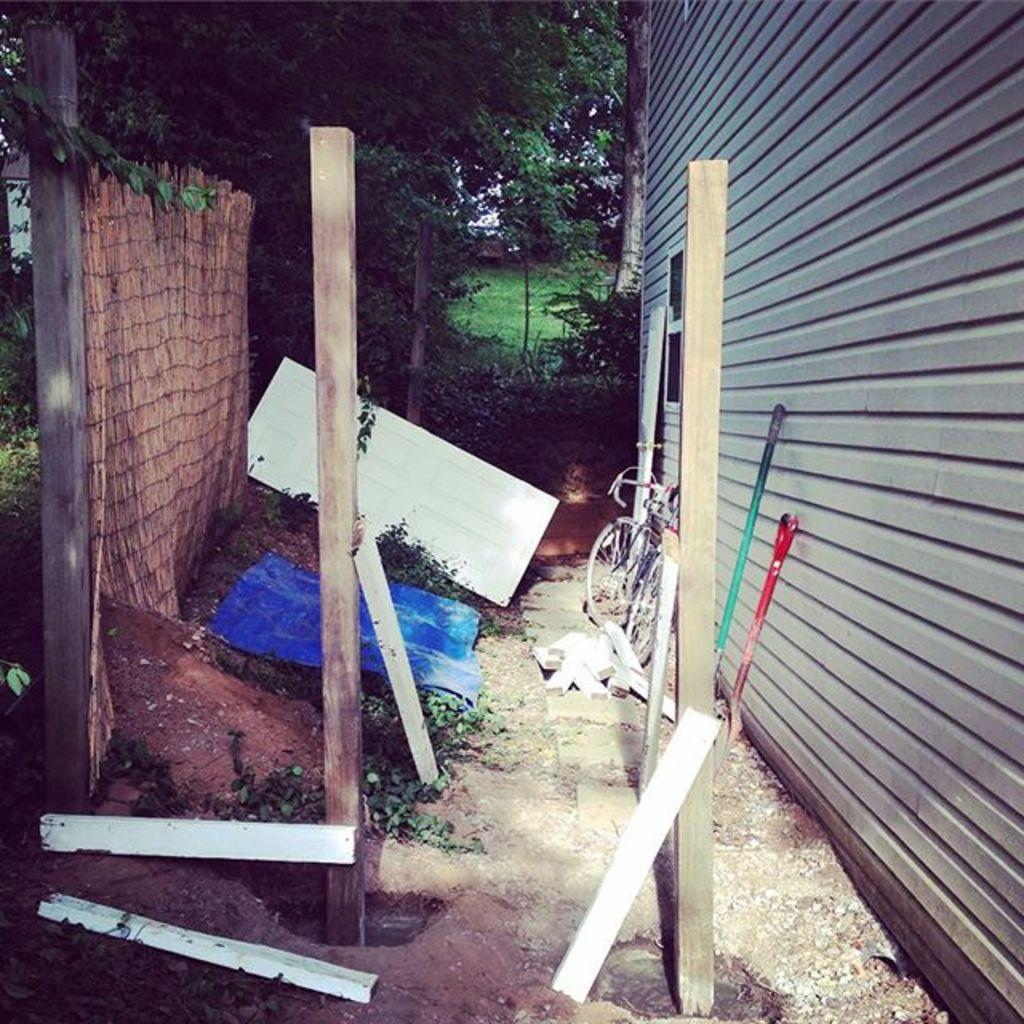What is there is a bicycle in the image, what is its condition? The condition of the bicycle cannot be determined from the image. What are the wooden poles used for in the image? The purpose of the wooden poles cannot be determined from the image. What is the wall made of in the image? The material of the wall cannot be determined from the image. What type of trees and plants are present in the image? The specific types of trees and plants cannot be determined from the image. Can you tell me how many pears are on the bicycle in the image? There are no pears present in the image. What type of butter is being used to grease the wooden poles in the image? There is no butter present in the image, and the wooden poles do not appear to be greased. 